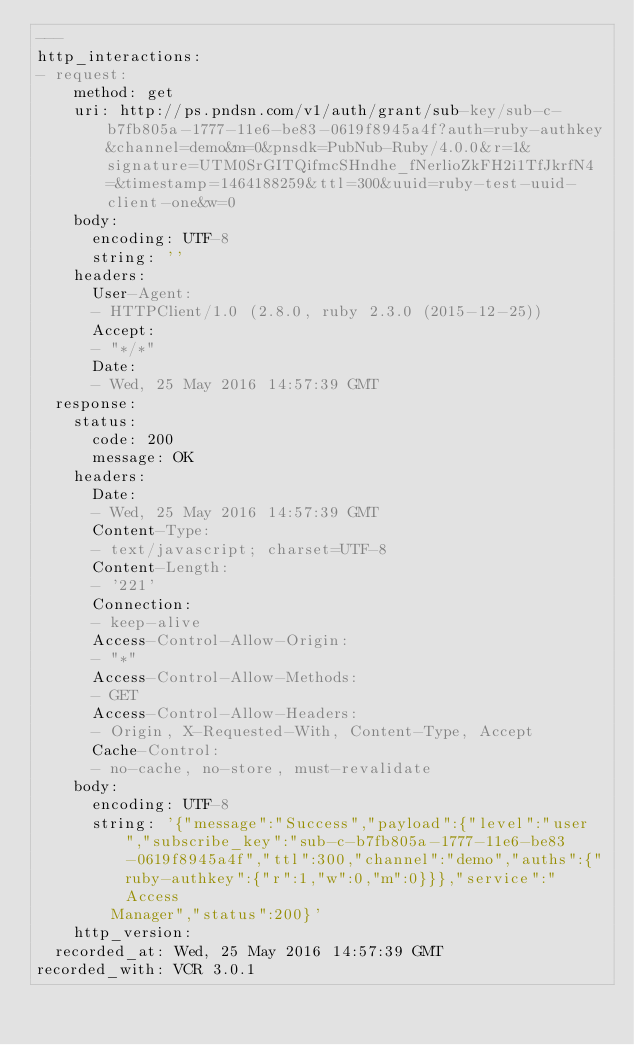Convert code to text. <code><loc_0><loc_0><loc_500><loc_500><_YAML_>---
http_interactions:
- request:
    method: get
    uri: http://ps.pndsn.com/v1/auth/grant/sub-key/sub-c-b7fb805a-1777-11e6-be83-0619f8945a4f?auth=ruby-authkey&channel=demo&m=0&pnsdk=PubNub-Ruby/4.0.0&r=1&signature=UTM0SrGITQifmcSHndhe_fNerlioZkFH2i1TfJkrfN4=&timestamp=1464188259&ttl=300&uuid=ruby-test-uuid-client-one&w=0
    body:
      encoding: UTF-8
      string: ''
    headers:
      User-Agent:
      - HTTPClient/1.0 (2.8.0, ruby 2.3.0 (2015-12-25))
      Accept:
      - "*/*"
      Date:
      - Wed, 25 May 2016 14:57:39 GMT
  response:
    status:
      code: 200
      message: OK
    headers:
      Date:
      - Wed, 25 May 2016 14:57:39 GMT
      Content-Type:
      - text/javascript; charset=UTF-8
      Content-Length:
      - '221'
      Connection:
      - keep-alive
      Access-Control-Allow-Origin:
      - "*"
      Access-Control-Allow-Methods:
      - GET
      Access-Control-Allow-Headers:
      - Origin, X-Requested-With, Content-Type, Accept
      Cache-Control:
      - no-cache, no-store, must-revalidate
    body:
      encoding: UTF-8
      string: '{"message":"Success","payload":{"level":"user","subscribe_key":"sub-c-b7fb805a-1777-11e6-be83-0619f8945a4f","ttl":300,"channel":"demo","auths":{"ruby-authkey":{"r":1,"w":0,"m":0}}},"service":"Access
        Manager","status":200}'
    http_version: 
  recorded_at: Wed, 25 May 2016 14:57:39 GMT
recorded_with: VCR 3.0.1
</code> 